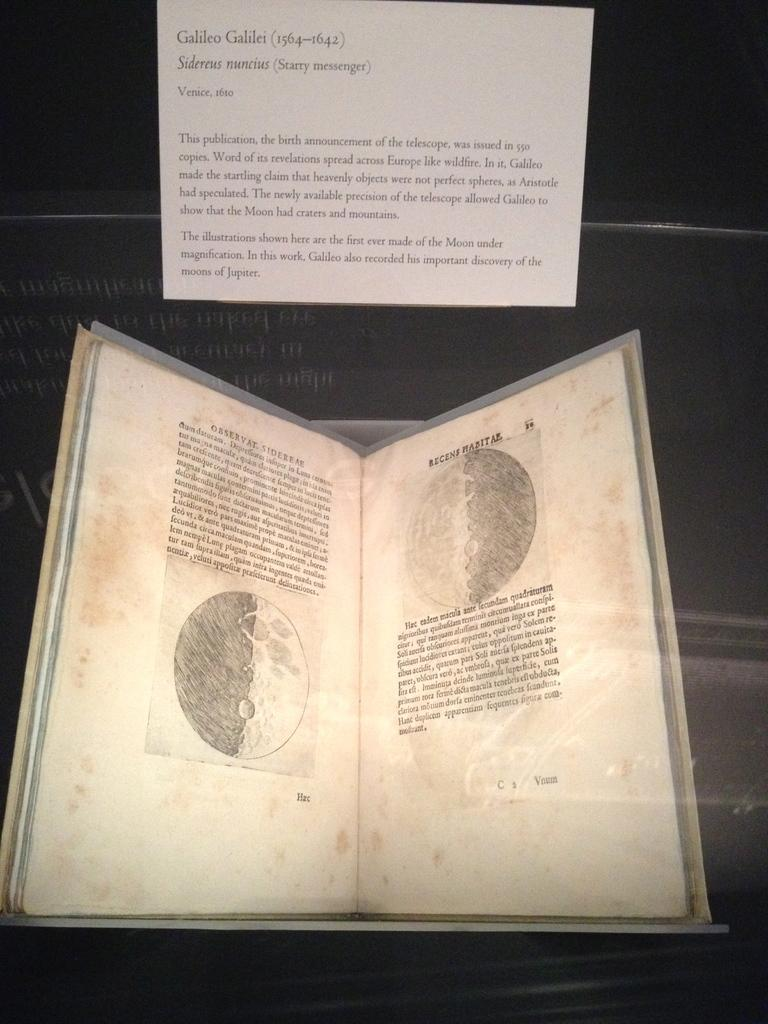<image>
Render a clear and concise summary of the photo. A portion of an exhibit refers to the historical figure named Galileo. 